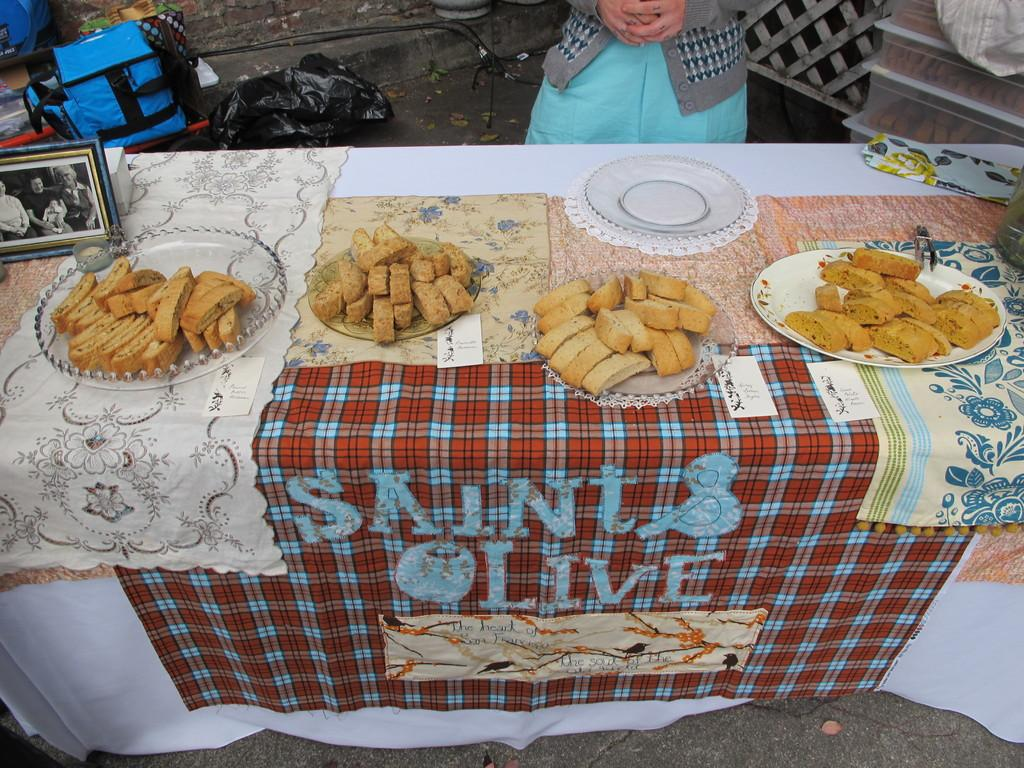What can be found on the table in the image? There are food items and a photo frame on the table. Who is present in the image? A woman is standing next to the table. What is located near the table? There is a bag and a plastic cover near the table. What type of jam is being served in the photo frame? There is no jam present in the image, and the photo frame is not serving any food items. 